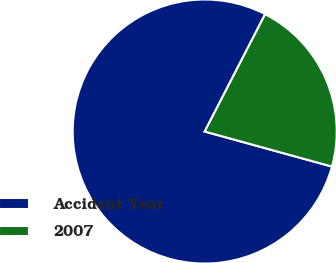Convert chart. <chart><loc_0><loc_0><loc_500><loc_500><pie_chart><fcel>Accident Year<fcel>2007<nl><fcel>78.29%<fcel>21.71%<nl></chart> 